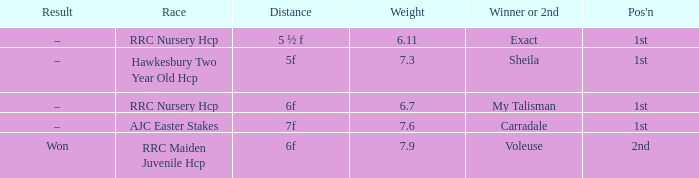What was the distance when the weight was 6.11? 5 ½ f. 